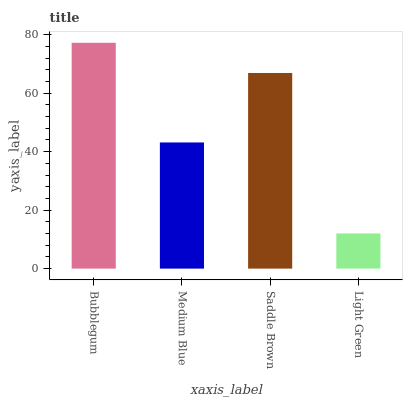Is Light Green the minimum?
Answer yes or no. Yes. Is Bubblegum the maximum?
Answer yes or no. Yes. Is Medium Blue the minimum?
Answer yes or no. No. Is Medium Blue the maximum?
Answer yes or no. No. Is Bubblegum greater than Medium Blue?
Answer yes or no. Yes. Is Medium Blue less than Bubblegum?
Answer yes or no. Yes. Is Medium Blue greater than Bubblegum?
Answer yes or no. No. Is Bubblegum less than Medium Blue?
Answer yes or no. No. Is Saddle Brown the high median?
Answer yes or no. Yes. Is Medium Blue the low median?
Answer yes or no. Yes. Is Medium Blue the high median?
Answer yes or no. No. Is Bubblegum the low median?
Answer yes or no. No. 